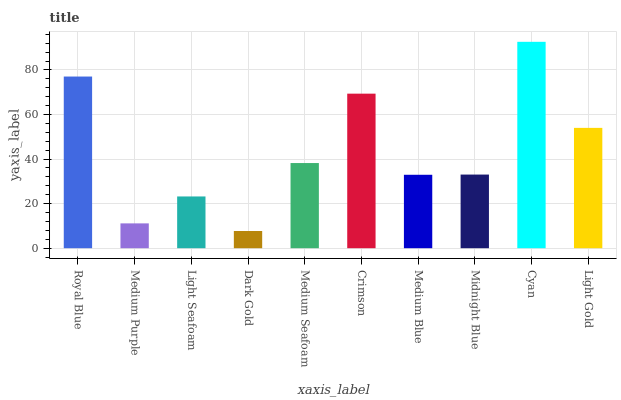Is Dark Gold the minimum?
Answer yes or no. Yes. Is Cyan the maximum?
Answer yes or no. Yes. Is Medium Purple the minimum?
Answer yes or no. No. Is Medium Purple the maximum?
Answer yes or no. No. Is Royal Blue greater than Medium Purple?
Answer yes or no. Yes. Is Medium Purple less than Royal Blue?
Answer yes or no. Yes. Is Medium Purple greater than Royal Blue?
Answer yes or no. No. Is Royal Blue less than Medium Purple?
Answer yes or no. No. Is Medium Seafoam the high median?
Answer yes or no. Yes. Is Midnight Blue the low median?
Answer yes or no. Yes. Is Midnight Blue the high median?
Answer yes or no. No. Is Light Seafoam the low median?
Answer yes or no. No. 